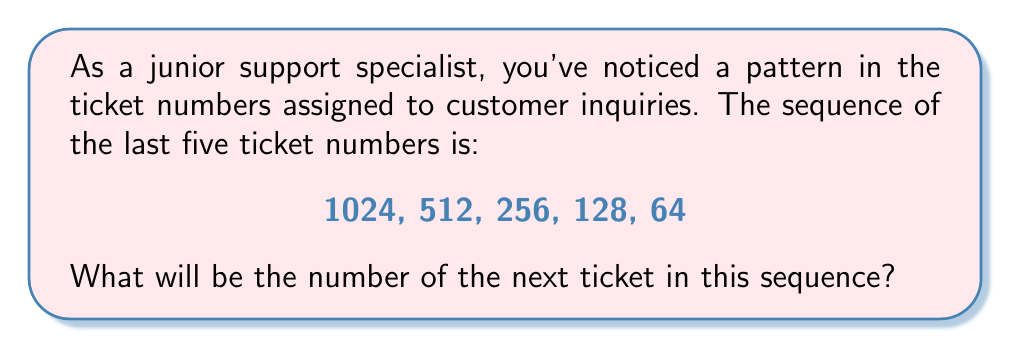Solve this math problem. Let's approach this step-by-step:

1) First, observe the given sequence: 1024, 512, 256, 128, 64

2) To find the pattern, let's look at the relationship between consecutive terms:

   $\frac{1024}{512} = 2$
   $\frac{512}{256} = 2$
   $\frac{256}{128} = 2$
   $\frac{128}{64} = 2$

3) We can see that each number is half of the previous number. In mathematical terms, we can express this as:

   $a_{n+1} = \frac{a_n}{2}$

   Where $a_n$ represents the nth term in the sequence.

4) To find the next number, we need to apply this rule to the last number in the given sequence:

   $\text{Next number} = \frac{64}{2} = 32$

Therefore, the next ticket number in the sequence will be 32.
Answer: 32 